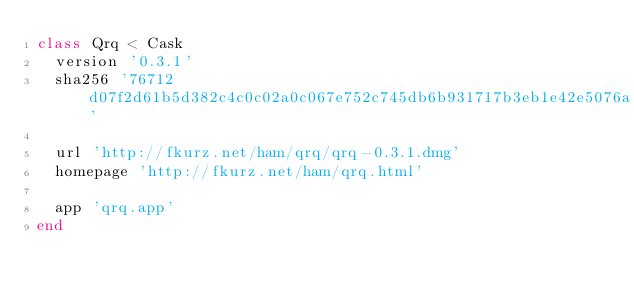<code> <loc_0><loc_0><loc_500><loc_500><_Ruby_>class Qrq < Cask
  version '0.3.1'
  sha256 '76712d07f2d61b5d382c4c0c02a0c067e752c745db6b931717b3eb1e42e5076a'

  url 'http://fkurz.net/ham/qrq/qrq-0.3.1.dmg'
  homepage 'http://fkurz.net/ham/qrq.html'

  app 'qrq.app'
end
</code> 